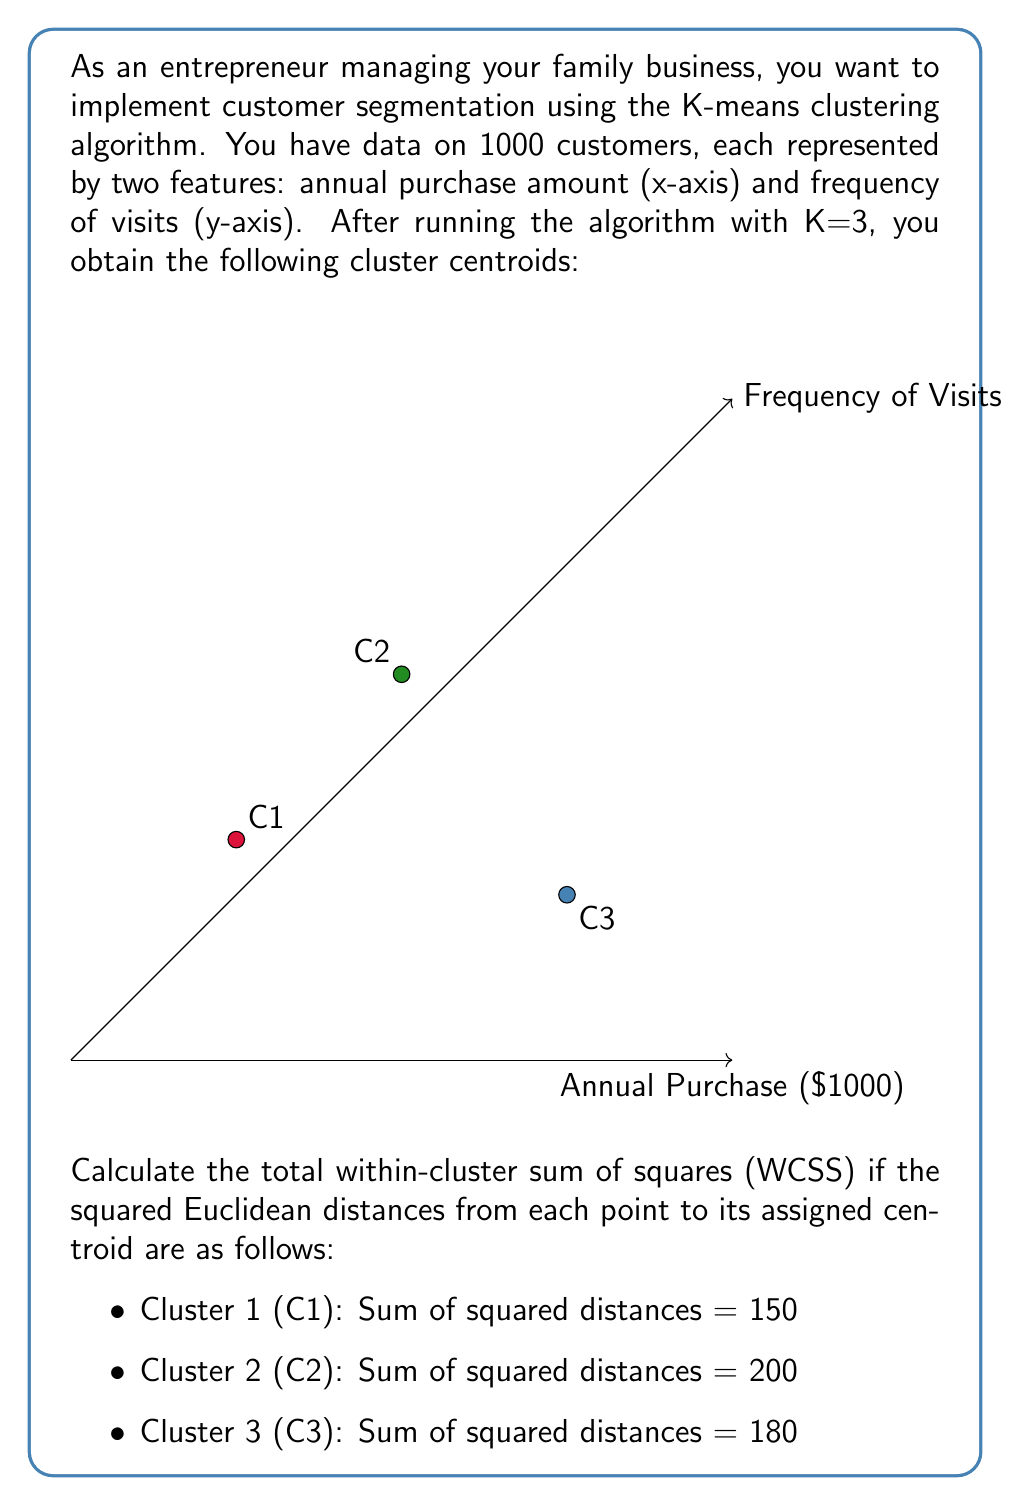Help me with this question. To solve this problem, we need to understand the concept of Within-Cluster Sum of Squares (WCSS) in K-means clustering. WCSS is a measure of the compactness of the clusters, calculated as the sum of the squared distances between each data point and its assigned cluster centroid.

Given:
- We have 3 clusters (K=3)
- Sum of squared distances for Cluster 1 (C1) = 150
- Sum of squared distances for Cluster 2 (C2) = 200
- Sum of squared distances for Cluster 3 (C3) = 180

Step 1: Recall the formula for WCSS
$$ WCSS = \sum_{i=1}^{K} \sum_{x \in C_i} ||x - \mu_i||^2 $$
Where:
- K is the number of clusters
- $C_i$ is the i-th cluster
- x is a data point in cluster $C_i$
- $\mu_i$ is the centroid of cluster $C_i$

Step 2: Substitute the given values into the formula
$$ WCSS = \sum_{x \in C_1} ||x - \mu_1||^2 + \sum_{x \in C_2} ||x - \mu_2||^2 + \sum_{x \in C_3} ||x - \mu_3||^2 $$

Step 3: Use the provided sums of squared distances for each cluster
$$ WCSS = 150 + 200 + 180 $$

Step 4: Calculate the total WCSS
$$ WCSS = 530 $$

This result represents the total within-cluster variation across all three customer segments. A lower WCSS indicates more compact and well-separated clusters, which is desirable for effective customer segmentation.
Answer: 530 